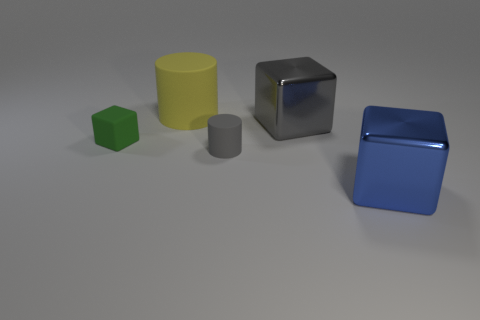Subtract all green cubes. How many cubes are left? 2 Add 2 tiny green matte objects. How many objects exist? 7 Subtract all cylinders. How many objects are left? 3 Subtract all brown blocks. Subtract all blue balls. How many blocks are left? 3 Add 1 purple metallic cylinders. How many purple metallic cylinders exist? 1 Subtract 1 green cubes. How many objects are left? 4 Subtract all big yellow objects. Subtract all blue metal things. How many objects are left? 3 Add 4 green cubes. How many green cubes are left? 5 